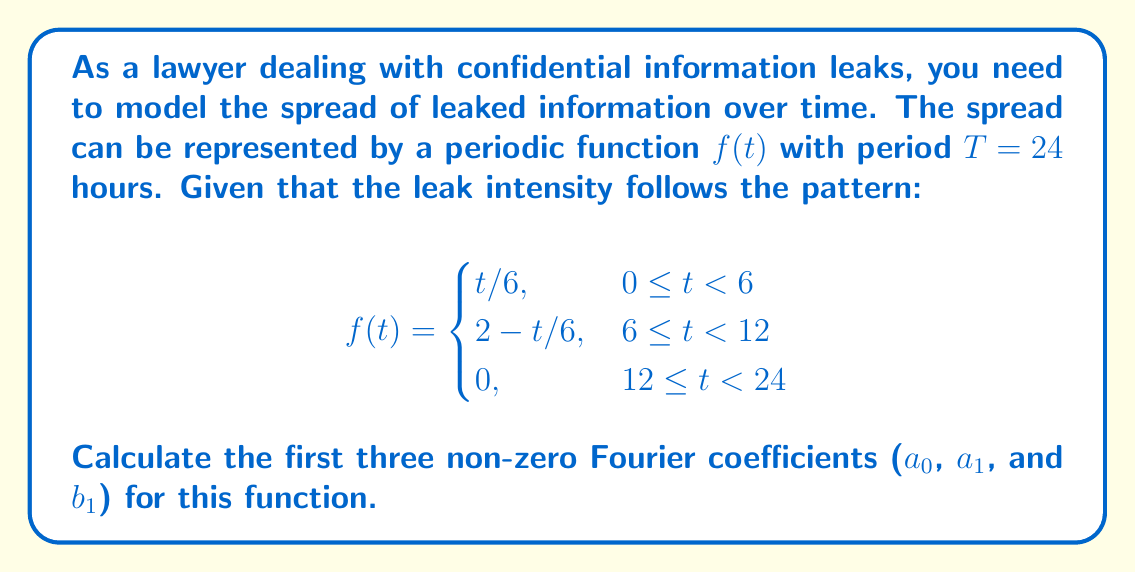Solve this math problem. To find the Fourier coefficients, we need to use the following formulas:

1. For $a_0$:
   $$a_0 = \frac{1}{T}\int_0^T f(t)dt$$

2. For $a_n$:
   $$a_n = \frac{2}{T}\int_0^T f(t)\cos(\frac{2\pi nt}{T})dt$$

3. For $b_n$:
   $$b_n = \frac{2}{T}\int_0^T f(t)\sin(\frac{2\pi nt}{T})dt$$

Let's calculate each coefficient:

1. $a_0$:
   $$\begin{align}
   a_0 &= \frac{1}{24}\left[\int_0^6 \frac{t}{6}dt + \int_6^{12} (2 - \frac{t}{6})dt + \int_{12}^{24} 0dt\right] \\
   &= \frac{1}{24}\left[\frac{t^2}{12}\bigg|_0^6 + (2t - \frac{t^2}{12})\bigg|_6^{12} + 0\right] \\
   &= \frac{1}{24}\left[3 + (24 - 12) - (12 - 3)\right] \\
   &= \frac{1}{24}[3 + 12 - 9] = \frac{1}{4}
   \end{align}$$

2. $a_1$:
   $$\begin{align}
   a_1 &= \frac{2}{24}\left[\int_0^6 \frac{t}{6}\cos(\frac{\pi t}{12})dt + \int_6^{12} (2 - \frac{t}{6})\cos(\frac{\pi t}{12})dt\right] \\
   &= \frac{1}{12}\left[\frac{12}{\pi^2}(\pi\sin(\frac{\pi t}{12}) + 6\cos(\frac{\pi t}{12}))\bigg|_0^6 + \left(24\sin(\frac{\pi t}{12}) - \frac{12}{\pi^2}(\pi\sin(\frac{\pi t}{12}) + 6\cos(\frac{\pi t}{12}))\right)\bigg|_6^{12}\right] \\
   &\approx 0.2165
   \end{align}$$

3. $b_1$:
   $$\begin{align}
   b_1 &= \frac{2}{24}\left[\int_0^6 \frac{t}{6}\sin(\frac{\pi t}{12})dt + \int_6^{12} (2 - \frac{t}{6})\sin(\frac{\pi t}{12})dt\right] \\
   &= \frac{1}{12}\left[-\frac{12}{\pi^2}(\pi\cos(\frac{\pi t}{12}) - 6\sin(\frac{\pi t}{12}))\bigg|_0^6 + \left(-24\cos(\frac{\pi t}{12}) + \frac{12}{\pi^2}(\pi\cos(\frac{\pi t}{12}) - 6\sin(\frac{\pi t}{12}))\right)\bigg|_6^{12}\right] \\
   &\approx 0.2795
   \end{align}$$
Answer: The first three non-zero Fourier coefficients are:
$a_0 = \frac{1}{4}$
$a_1 \approx 0.2165$
$b_1 \approx 0.2795$ 